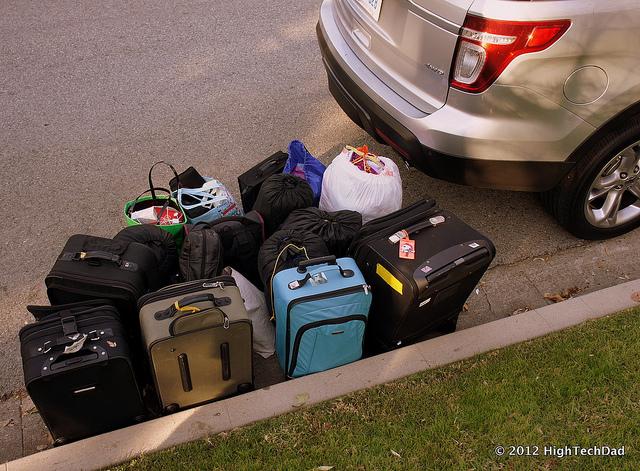Which bag is sky blue?
Answer briefly. Front second from right. How many white bags are there?
Write a very short answer. 1. How many suitcases are there?
Short answer required. 5. 